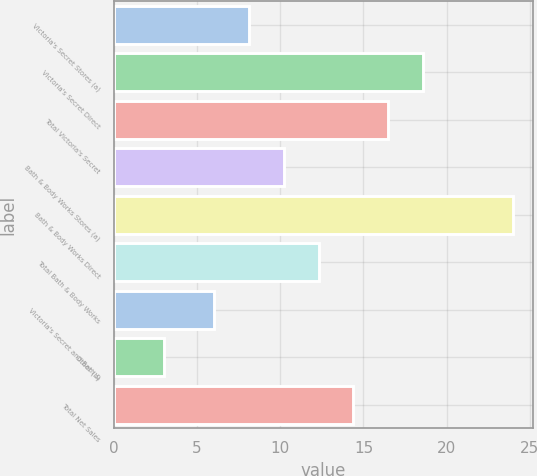Convert chart. <chart><loc_0><loc_0><loc_500><loc_500><bar_chart><fcel>Victoria's Secret Stores (a)<fcel>Victoria's Secret Direct<fcel>Total Victoria's Secret<fcel>Bath & Body Works Stores (a)<fcel>Bath & Body Works Direct<fcel>Total Bath & Body Works<fcel>Victoria's Secret and Bath &<fcel>Other (b)<fcel>Total Net Sales<nl><fcel>8.1<fcel>18.6<fcel>16.5<fcel>10.2<fcel>24<fcel>12.3<fcel>6<fcel>3<fcel>14.4<nl></chart> 